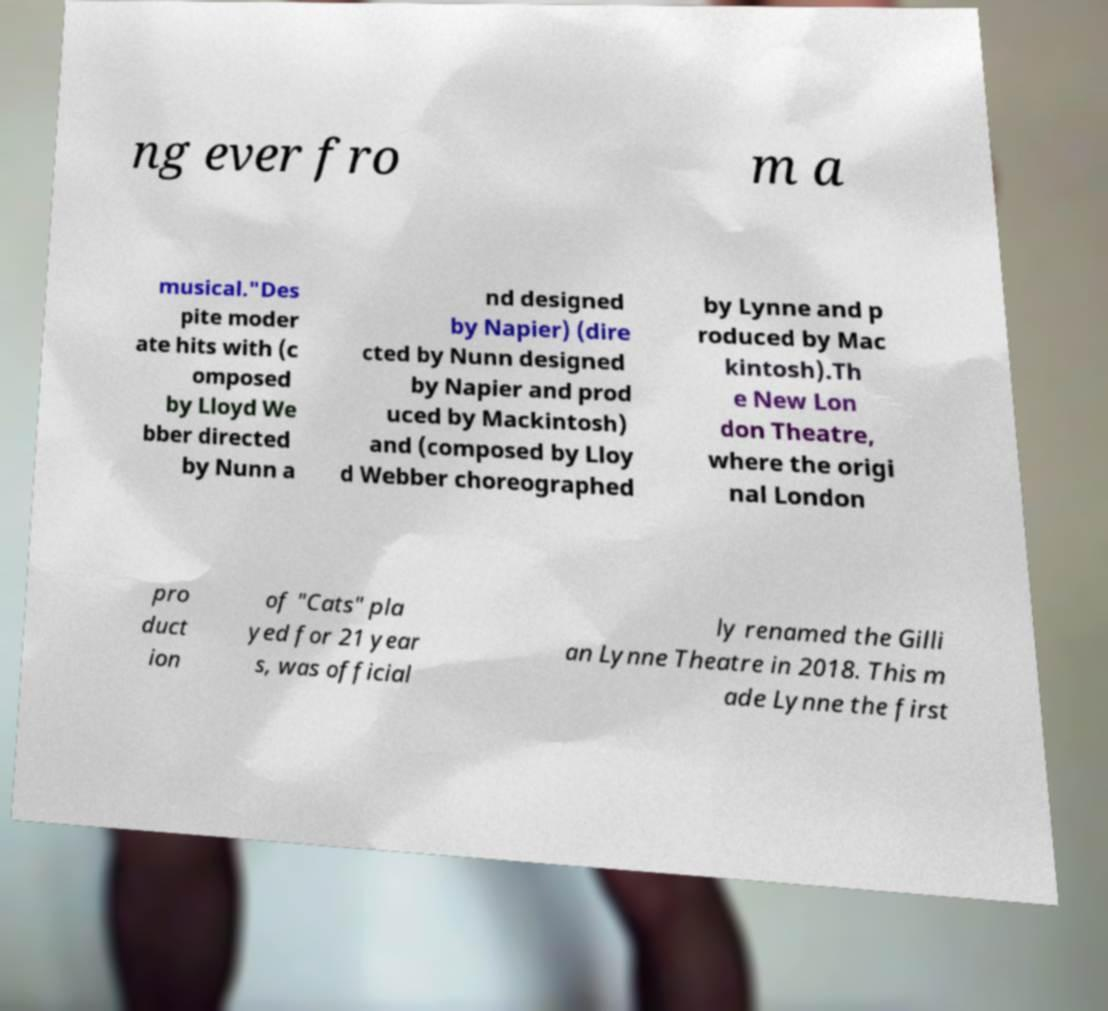Please read and relay the text visible in this image. What does it say? ng ever fro m a musical."Des pite moder ate hits with (c omposed by Lloyd We bber directed by Nunn a nd designed by Napier) (dire cted by Nunn designed by Napier and prod uced by Mackintosh) and (composed by Lloy d Webber choreographed by Lynne and p roduced by Mac kintosh).Th e New Lon don Theatre, where the origi nal London pro duct ion of "Cats" pla yed for 21 year s, was official ly renamed the Gilli an Lynne Theatre in 2018. This m ade Lynne the first 